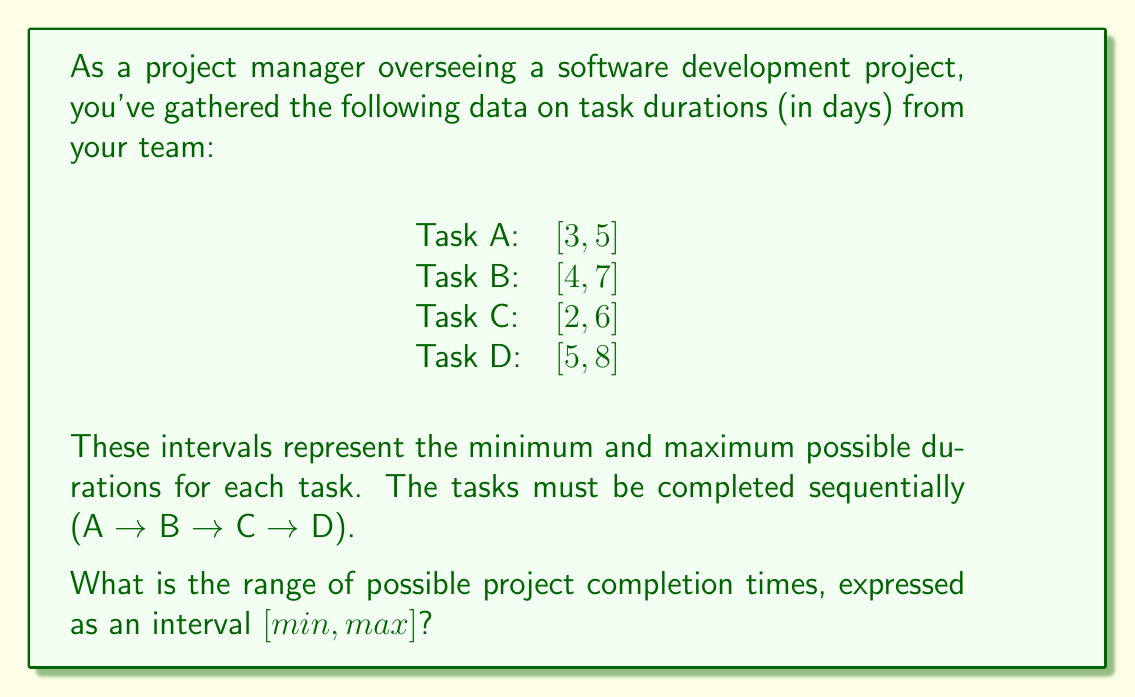Give your solution to this math problem. To solve this problem, we need to consider the best-case and worst-case scenarios for the project completion time.

1. Best-case scenario (minimum completion time):
   We sum up the minimum durations for each task.
   $$min = 3 + 4 + 2 + 5 = 14\text{ days}$$

2. Worst-case scenario (maximum completion time):
   We sum up the maximum durations for each task.
   $$max = 5 + 7 + 6 + 8 = 26\text{ days}$$

3. The range of possible project completion times is represented by the interval $[min, max]$.

This approach aligns with the project manager's value of open communication, as it incorporates the team's input on task duration uncertainties to provide a realistic range for project completion.
Answer: The range of possible project completion times is $[14, 26]$ days. 